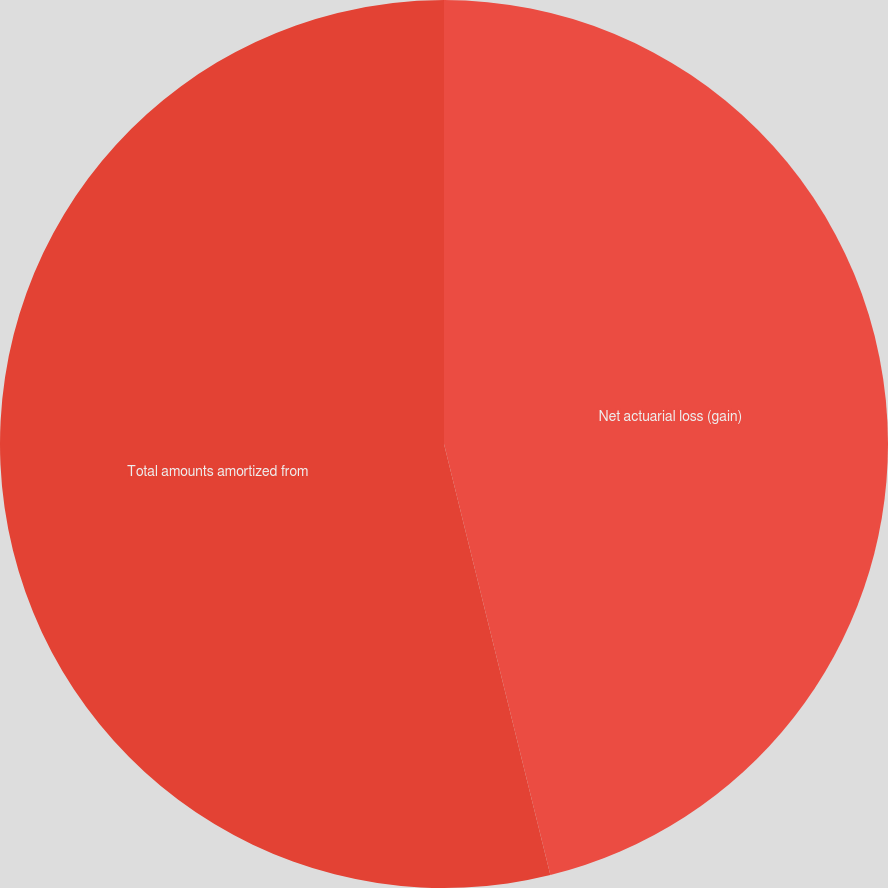Convert chart. <chart><loc_0><loc_0><loc_500><loc_500><pie_chart><fcel>Net actuarial loss (gain)<fcel>Total amounts amortized from<nl><fcel>46.15%<fcel>53.85%<nl></chart> 